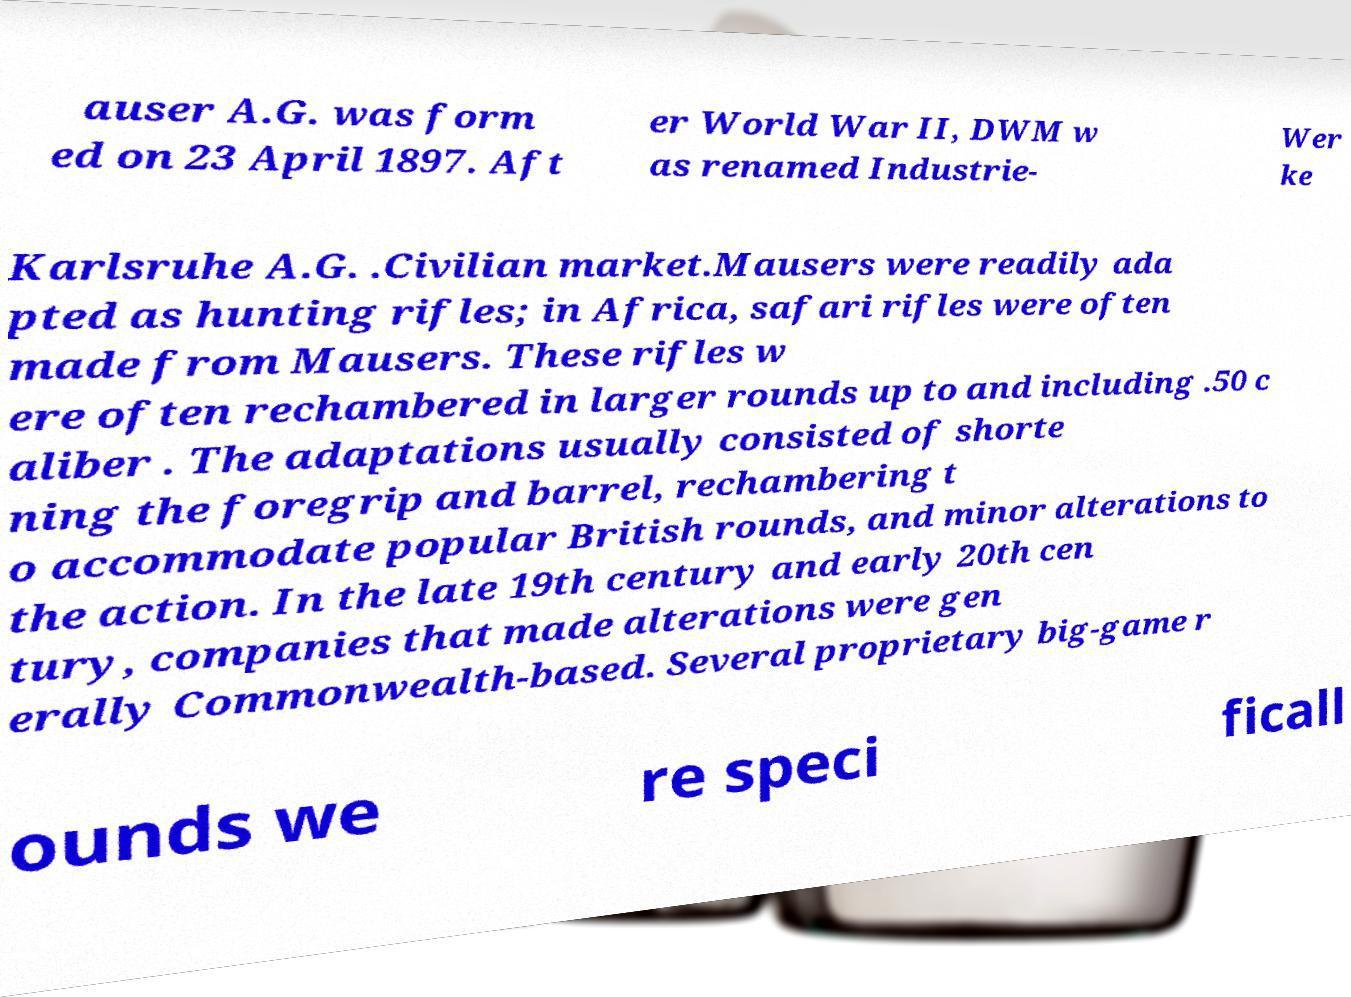There's text embedded in this image that I need extracted. Can you transcribe it verbatim? auser A.G. was form ed on 23 April 1897. Aft er World War II, DWM w as renamed Industrie- Wer ke Karlsruhe A.G. .Civilian market.Mausers were readily ada pted as hunting rifles; in Africa, safari rifles were often made from Mausers. These rifles w ere often rechambered in larger rounds up to and including .50 c aliber . The adaptations usually consisted of shorte ning the foregrip and barrel, rechambering t o accommodate popular British rounds, and minor alterations to the action. In the late 19th century and early 20th cen tury, companies that made alterations were gen erally Commonwealth-based. Several proprietary big-game r ounds we re speci ficall 